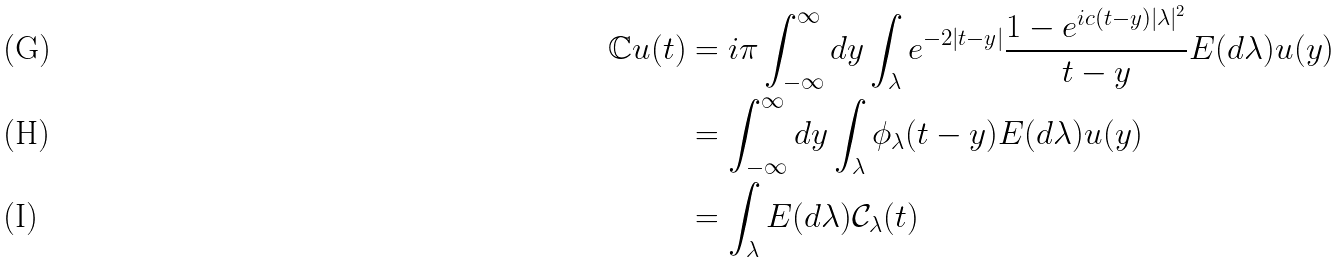<formula> <loc_0><loc_0><loc_500><loc_500>\mathbb { C } u ( t ) & = i \pi \int _ { - \infty } ^ { \infty } d y \int _ { \lambda } e ^ { - 2 | t - y | } \frac { 1 - e ^ { i c ( t - y ) | \lambda | ^ { 2 } } } { t - y } E ( d \lambda ) u ( y ) \\ & = \int _ { - \infty } ^ { \infty } d y \int _ { \lambda } \phi _ { \lambda } ( t - y ) E ( d \lambda ) u ( y ) \\ & = \int _ { \lambda } E ( d \lambda ) \mathcal { C } _ { \lambda } ( t )</formula> 